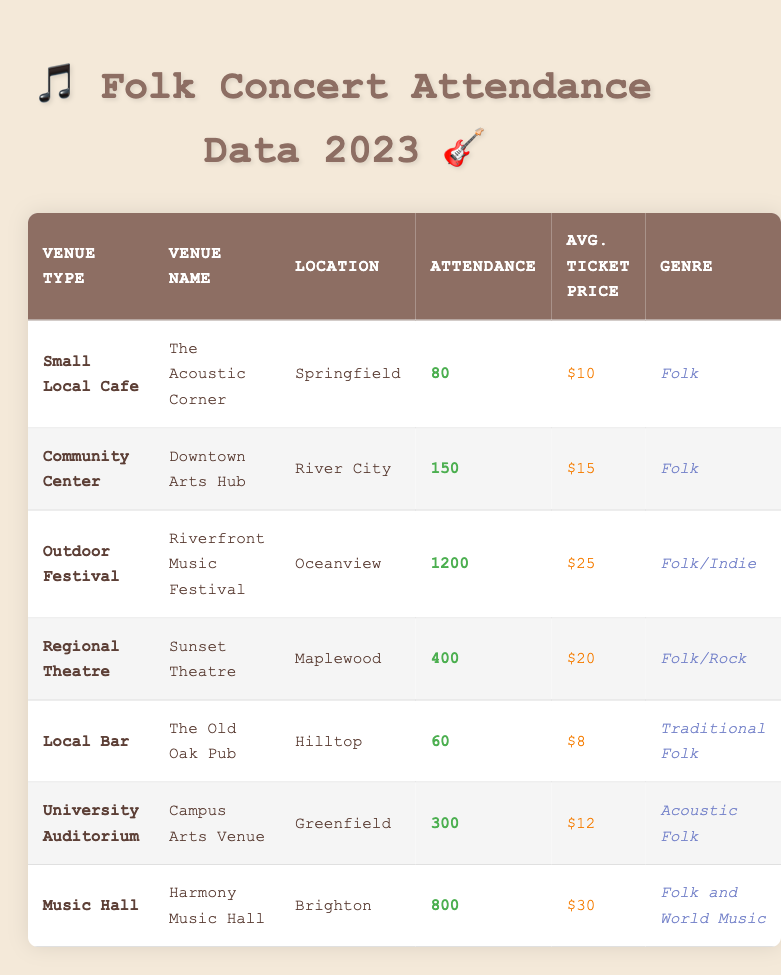What is the venue with the highest attendance? The venue with the highest attendance can be found by comparing the attendance numbers in the table. The Outdoor Festival at the Riverfront Music Festival has an attendance of 1200, which is greater than all other venues listed.
Answer: Riverfront Music Festival What is the average ticket price at community venues? To find the average ticket price for community venues, we first identify the relevant venues: Downtown Arts Hub (Community Center - $15), Campus Arts Venue (University Auditorium - $12), and The Old Oak Pub (Local Bar - $8). The total ticket price for these is $15 + $12 + $8 = $35. There are three venues, so the average ticket price is 35 / 3 = 11.67, which rounds to approximately $11.67.
Answer: 11.67 Is the attendance at The Acoustic Corner greater than that of The Old Oak Pub? We compare the attendance numbers directly from the table: The Acoustic Corner has 80 attendees, while The Old Oak Pub has 60. Since 80 is greater than 60, the statement is true.
Answer: Yes What is the total attendance across all venues? To find the total attendance, we add up the attendance figures for each venue: 80 + 150 + 1200 + 400 + 60 + 300 + 800 = 2990. This provides the total attendance across all listed venues in the table.
Answer: 2990 Which genre has the highest average ticket price? We first identify ticket prices for each genre: Folk ($10), Folk ($15), Folk/Indie ($25), Folk/Rock ($20), Traditional Folk ($8), Acoustic Folk ($12), Folk and World Music ($30). We calculate the average ticket price: Folk (2 venues: avg is (10 + 15)/2 = 12.5), Folk/Indie (25), Folk/Rock (20), Traditional Folk (8), Acoustic Folk (12), Folk and World Music (30). The highest average is for Folk and World Music at $30.
Answer: Folk and World Music What is the attendance difference between the highest and lowest venues? The highest attendance is at the Riverfront Music Festival with 1200 attendees, and the lowest attendance is at The Old Oak Pub with 60 attendees. The difference is calculated as 1200 - 60 = 1140.
Answer: 1140 